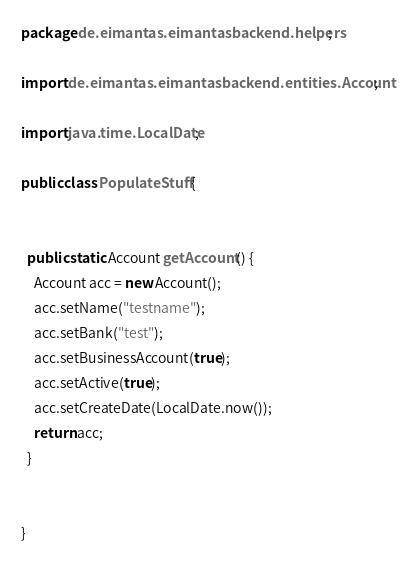Convert code to text. <code><loc_0><loc_0><loc_500><loc_500><_Java_>package de.eimantas.eimantasbackend.helpers;

import de.eimantas.eimantasbackend.entities.Account;

import java.time.LocalDate;

public class PopulateStuff {


  public static Account getAccount() {
    Account acc = new Account();
    acc.setName("testname");
    acc.setBank("test");
    acc.setBusinessAccount(true);
    acc.setActive(true);
    acc.setCreateDate(LocalDate.now());
    return acc;
  }


}
</code> 